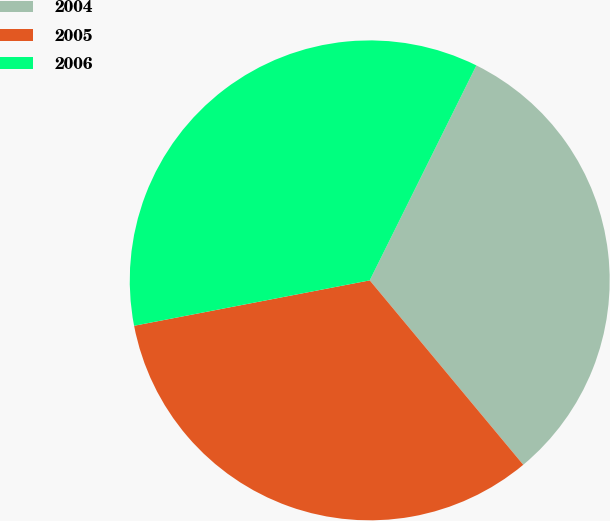<chart> <loc_0><loc_0><loc_500><loc_500><pie_chart><fcel>2004<fcel>2005<fcel>2006<nl><fcel>31.62%<fcel>33.02%<fcel>35.36%<nl></chart> 